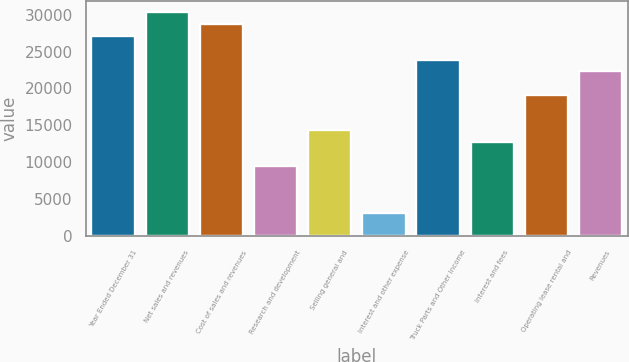Convert chart to OTSL. <chart><loc_0><loc_0><loc_500><loc_500><bar_chart><fcel>Year Ended December 31<fcel>Net sales and revenues<fcel>Cost of sales and revenues<fcel>Research and development<fcel>Selling general and<fcel>Interest and other expense<fcel>Truck Parts and Other Income<fcel>Interest and fees<fcel>Operating lease rental and<fcel>Revenues<nl><fcel>27110.8<fcel>30299.9<fcel>28705.4<fcel>9570.66<fcel>14354.3<fcel>3192.42<fcel>23921.7<fcel>12759.8<fcel>19138<fcel>22327.1<nl></chart> 